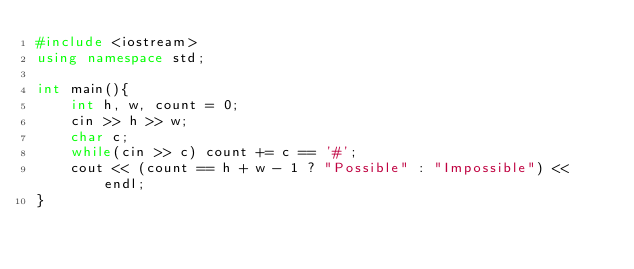Convert code to text. <code><loc_0><loc_0><loc_500><loc_500><_C++_>#include <iostream>
using namespace std;

int main(){
    int h, w, count = 0;
    cin >> h >> w;
    char c;
    while(cin >> c) count += c == '#';
    cout << (count == h + w - 1 ? "Possible" : "Impossible") << endl;
}</code> 